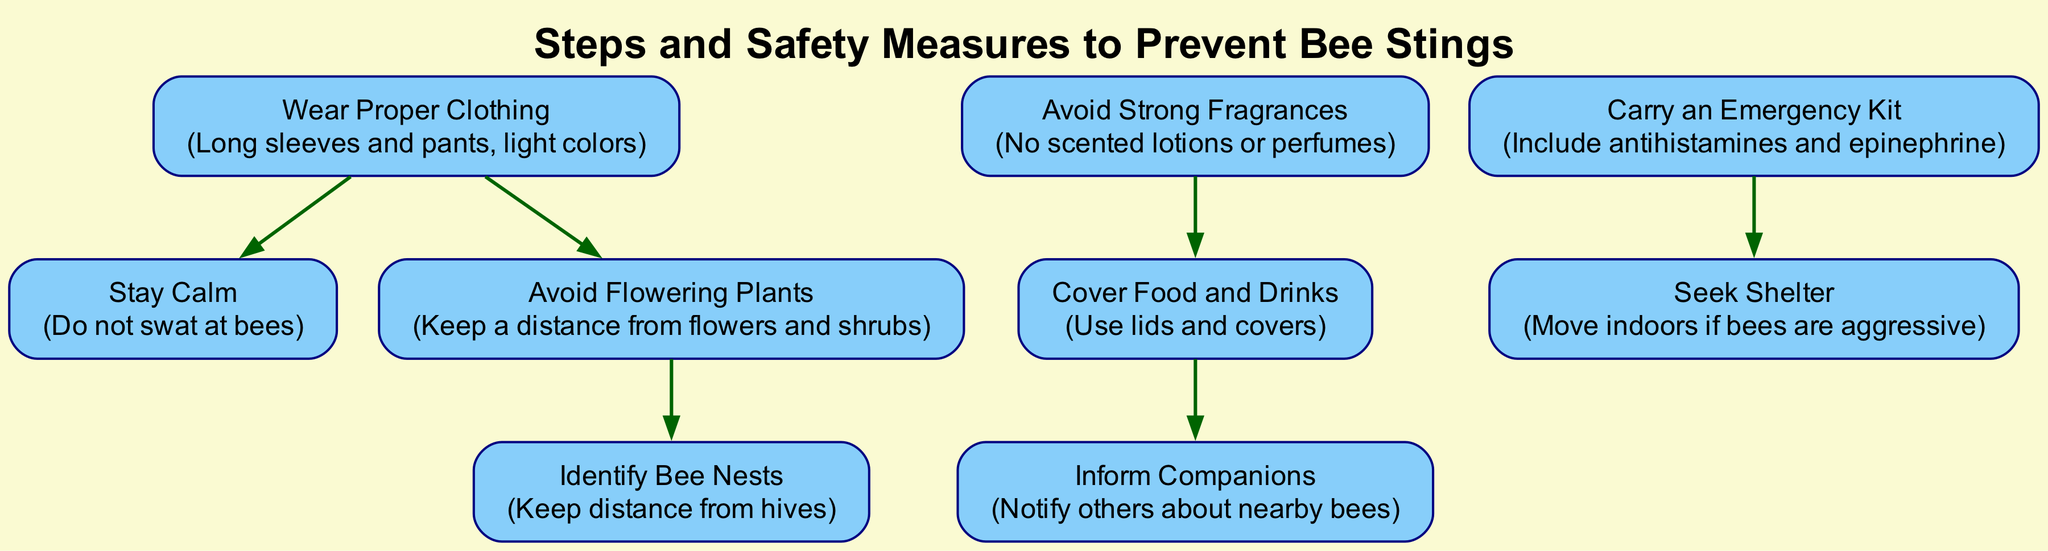what is the total number of nodes in the diagram? The diagram contains a list of nodes that represent various safety measures. By counting them, we can determine that there are eight nodes present.
Answer: 8 what is the relationship between "cover food and drinks" and "inform companions"? The diagram shows a directed edge leading from "cover food and drinks" to "inform companions," indicating that after covering food, it's important to inform others about nearby bees.
Answer: cover food and drinks → inform companions which measure suggests wearing long sleeves and pants? The node labeled "Wear Proper Clothing" specifies that wearing long sleeves and pants is one of the suggested measures to prevent bee stings.
Answer: Wear Proper Clothing how many edges connect the nodes in the diagram? By examining the connections between the nodes (the edges), the total count reveals that there are five edges present, illustrating the relationships among the various safety measures.
Answer: 5 what is the first step recommended after identifying bee nests? The directed edge from "Avoid Flowering Plants" to "Identify Bee Nests" suggests that after one avoids flowering plants, the next action involves identifying bee nests to keep distance.
Answer: Identify Bee Nests which node leads to seeking shelter from aggressive bees? The diagram shows that carrying an emergency kit, indicated by "Carry an Emergency Kit," directly leads to the node "Seek Shelter," indicating it’s a step taken when bees are aggressive.
Answer: Carry an Emergency Kit what safety measure is recommended for outdoor activities involving food? The node "Cover Food and Drinks" indicates that covering food and drinks is a specific safety measure suggested for outdoor activities.
Answer: Cover Food and Drinks which two nodes are not directly connected? The diagram can be analyzed to see that "Wear Proper Clothing" and "Carry an Emergency Kit" do not have a direct edge connecting them, indicating they are not directly related in the graph.
Answer: Wear Proper Clothing and Carry an Emergency Kit what is the last measure you should take if bees are aggressive? The node "Seek Shelter" specifically indicates that moving indoors is the final recommended action to take if bees exhibit aggressive behavior.
Answer: Seek Shelter 